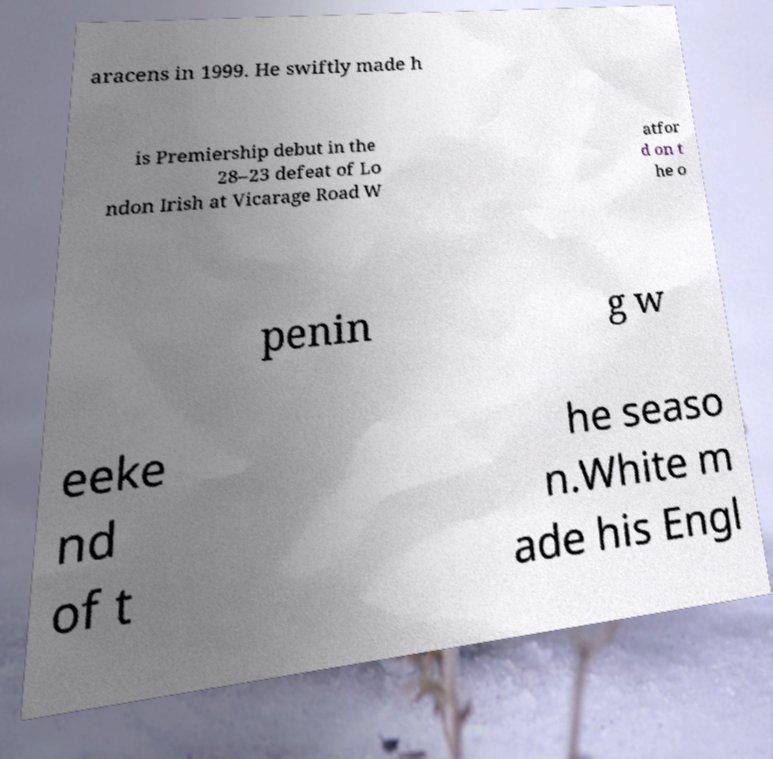What messages or text are displayed in this image? I need them in a readable, typed format. aracens in 1999. He swiftly made h is Premiership debut in the 28–23 defeat of Lo ndon Irish at Vicarage Road W atfor d on t he o penin g w eeke nd of t he seaso n.White m ade his Engl 